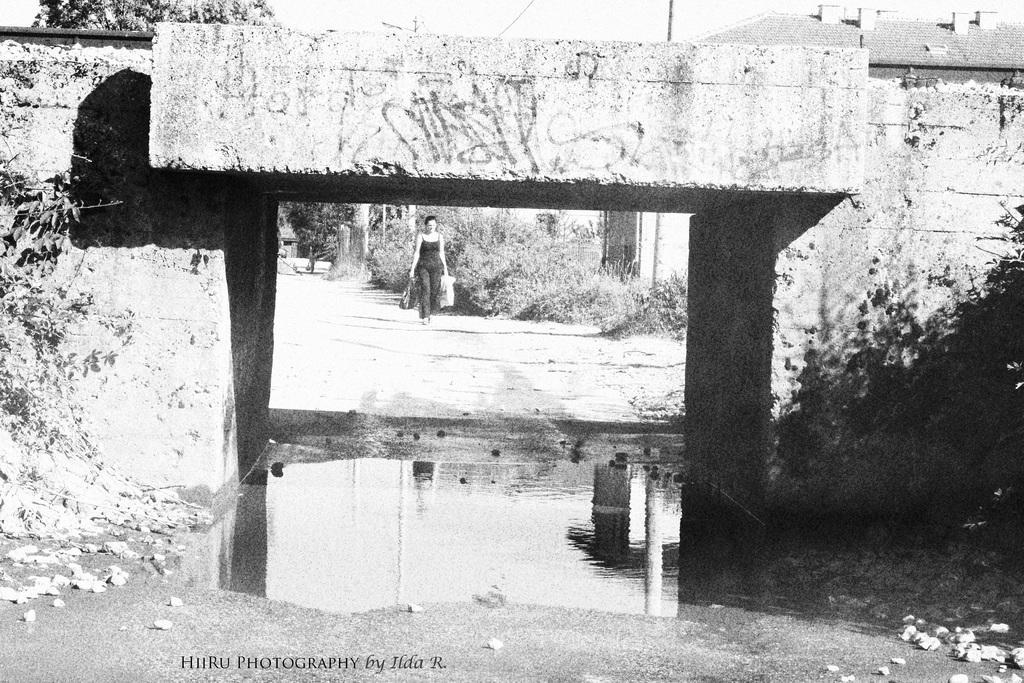In one or two sentences, can you explain what this image depicts? This looks like a black and white image. Here is a woman holding bags and walking. This is the water. I think this is the small railway bridge. These are the trees and bushes. At the bottom of the image, I can see the watermark. 